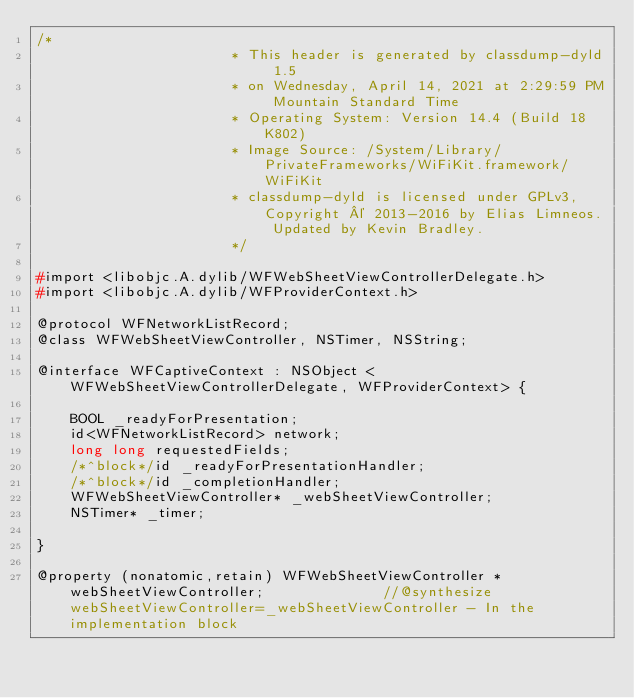<code> <loc_0><loc_0><loc_500><loc_500><_C_>/*
                       * This header is generated by classdump-dyld 1.5
                       * on Wednesday, April 14, 2021 at 2:29:59 PM Mountain Standard Time
                       * Operating System: Version 14.4 (Build 18K802)
                       * Image Source: /System/Library/PrivateFrameworks/WiFiKit.framework/WiFiKit
                       * classdump-dyld is licensed under GPLv3, Copyright © 2013-2016 by Elias Limneos. Updated by Kevin Bradley.
                       */

#import <libobjc.A.dylib/WFWebSheetViewControllerDelegate.h>
#import <libobjc.A.dylib/WFProviderContext.h>

@protocol WFNetworkListRecord;
@class WFWebSheetViewController, NSTimer, NSString;

@interface WFCaptiveContext : NSObject <WFWebSheetViewControllerDelegate, WFProviderContext> {

	BOOL _readyForPresentation;
	id<WFNetworkListRecord> network;
	long long requestedFields;
	/*^block*/id _readyForPresentationHandler;
	/*^block*/id _completionHandler;
	WFWebSheetViewController* _webSheetViewController;
	NSTimer* _timer;

}

@property (nonatomic,retain) WFWebSheetViewController * webSheetViewController;              //@synthesize webSheetViewController=_webSheetViewController - In the implementation block</code> 